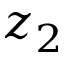Convert formula to latex. <formula><loc_0><loc_0><loc_500><loc_500>z _ { 2 }</formula> 